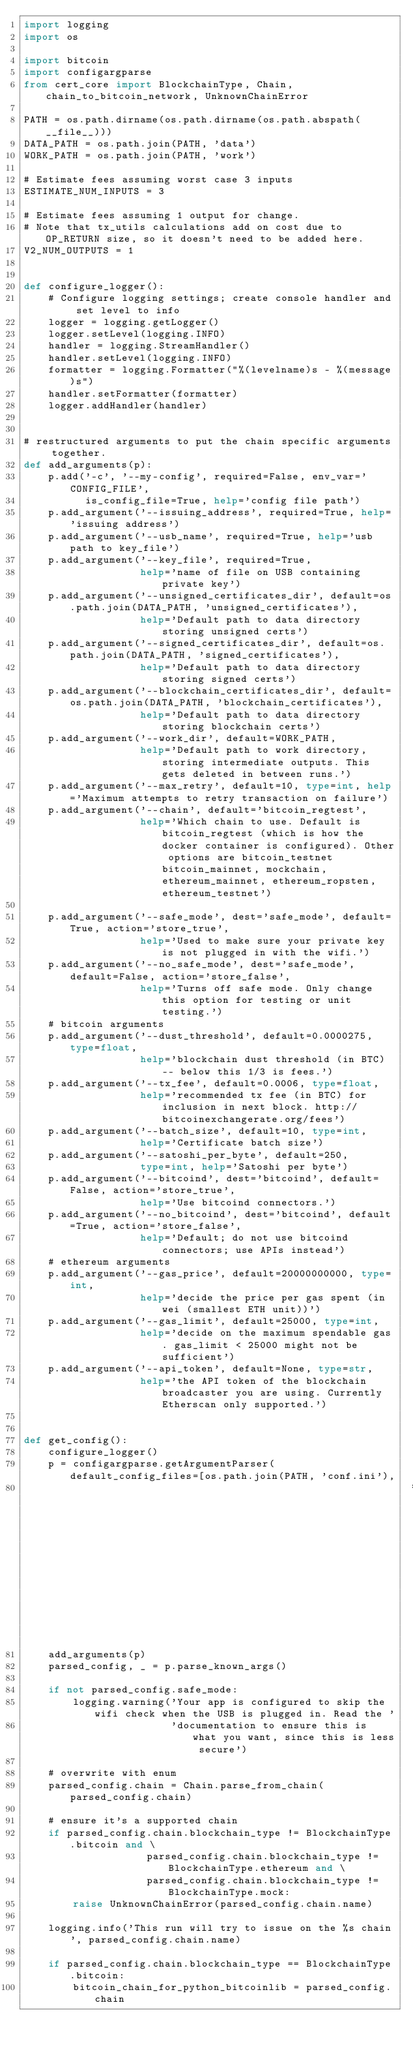Convert code to text. <code><loc_0><loc_0><loc_500><loc_500><_Python_>import logging
import os

import bitcoin
import configargparse
from cert_core import BlockchainType, Chain, chain_to_bitcoin_network, UnknownChainError

PATH = os.path.dirname(os.path.dirname(os.path.abspath(__file__)))
DATA_PATH = os.path.join(PATH, 'data')
WORK_PATH = os.path.join(PATH, 'work')

# Estimate fees assuming worst case 3 inputs
ESTIMATE_NUM_INPUTS = 3

# Estimate fees assuming 1 output for change.
# Note that tx_utils calculations add on cost due to OP_RETURN size, so it doesn't need to be added here.
V2_NUM_OUTPUTS = 1


def configure_logger():
    # Configure logging settings; create console handler and set level to info
    logger = logging.getLogger()
    logger.setLevel(logging.INFO)
    handler = logging.StreamHandler()
    handler.setLevel(logging.INFO)
    formatter = logging.Formatter("%(levelname)s - %(message)s")
    handler.setFormatter(formatter)
    logger.addHandler(handler)


# restructured arguments to put the chain specific arguments together.
def add_arguments(p):
    p.add('-c', '--my-config', required=False, env_var='CONFIG_FILE',
          is_config_file=True, help='config file path')
    p.add_argument('--issuing_address', required=True, help='issuing address')
    p.add_argument('--usb_name', required=True, help='usb path to key_file')
    p.add_argument('--key_file', required=True,
                   help='name of file on USB containing private key')
    p.add_argument('--unsigned_certificates_dir', default=os.path.join(DATA_PATH, 'unsigned_certificates'),
                   help='Default path to data directory storing unsigned certs')
    p.add_argument('--signed_certificates_dir', default=os.path.join(DATA_PATH, 'signed_certificates'),
                   help='Default path to data directory storing signed certs')
    p.add_argument('--blockchain_certificates_dir', default=os.path.join(DATA_PATH, 'blockchain_certificates'),
                   help='Default path to data directory storing blockchain certs')
    p.add_argument('--work_dir', default=WORK_PATH,
                   help='Default path to work directory, storing intermediate outputs. This gets deleted in between runs.')
    p.add_argument('--max_retry', default=10, type=int, help='Maximum attempts to retry transaction on failure')
    p.add_argument('--chain', default='bitcoin_regtest',
                   help='Which chain to use. Default is bitcoin_regtest (which is how the docker container is configured). Other options are bitcoin_testnet bitcoin_mainnet, mockchain, ethereum_mainnet, ethereum_ropsten, ethereum_testnet')

    p.add_argument('--safe_mode', dest='safe_mode', default=True, action='store_true',
                   help='Used to make sure your private key is not plugged in with the wifi.')
    p.add_argument('--no_safe_mode', dest='safe_mode', default=False, action='store_false',
                   help='Turns off safe mode. Only change this option for testing or unit testing.')
    # bitcoin arguments
    p.add_argument('--dust_threshold', default=0.0000275, type=float,
                   help='blockchain dust threshold (in BTC) -- below this 1/3 is fees.')
    p.add_argument('--tx_fee', default=0.0006, type=float,
                   help='recommended tx fee (in BTC) for inclusion in next block. http://bitcoinexchangerate.org/fees')
    p.add_argument('--batch_size', default=10, type=int,
                   help='Certificate batch size')
    p.add_argument('--satoshi_per_byte', default=250,
                   type=int, help='Satoshi per byte')
    p.add_argument('--bitcoind', dest='bitcoind', default=False, action='store_true',
                   help='Use bitcoind connectors.')
    p.add_argument('--no_bitcoind', dest='bitcoind', default=True, action='store_false',
                   help='Default; do not use bitcoind connectors; use APIs instead')
    # ethereum arguments
    p.add_argument('--gas_price', default=20000000000, type=int,
                   help='decide the price per gas spent (in wei (smallest ETH unit))')
    p.add_argument('--gas_limit', default=25000, type=int,
                   help='decide on the maximum spendable gas. gas_limit < 25000 might not be sufficient')
    p.add_argument('--api_token', default=None, type=str,
                   help='the API token of the blockchain broadcaster you are using. Currently Etherscan only supported.')


def get_config():
    configure_logger()
    p = configargparse.getArgumentParser(default_config_files=[os.path.join(PATH, 'conf.ini'),
                                                               '/etc/cert-issuer/conf.ini'])
    add_arguments(p)
    parsed_config, _ = p.parse_known_args()

    if not parsed_config.safe_mode:
        logging.warning('Your app is configured to skip the wifi check when the USB is plugged in. Read the '
                        'documentation to ensure this is what you want, since this is less secure')

    # overwrite with enum
    parsed_config.chain = Chain.parse_from_chain(parsed_config.chain)

    # ensure it's a supported chain
    if parsed_config.chain.blockchain_type != BlockchainType.bitcoin and \
                    parsed_config.chain.blockchain_type != BlockchainType.ethereum and \
                    parsed_config.chain.blockchain_type != BlockchainType.mock:
        raise UnknownChainError(parsed_config.chain.name)

    logging.info('This run will try to issue on the %s chain', parsed_config.chain.name)

    if parsed_config.chain.blockchain_type == BlockchainType.bitcoin:
        bitcoin_chain_for_python_bitcoinlib = parsed_config.chain</code> 